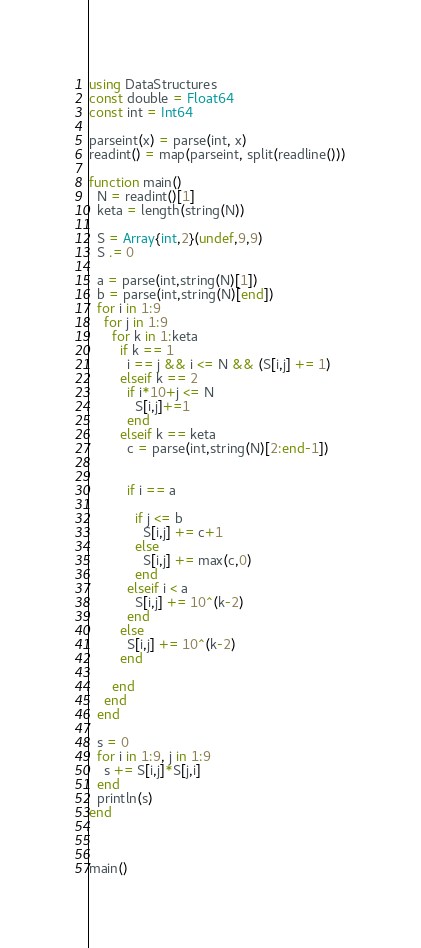Convert code to text. <code><loc_0><loc_0><loc_500><loc_500><_Julia_>using DataStructures
const double = Float64
const int = Int64

parseint(x) = parse(int, x)
readint() = map(parseint, split(readline()))

function main()
  N = readint()[1]
  keta = length(string(N))
  
  S = Array{int,2}(undef,9,9)
  S .= 0
  
  a = parse(int,string(N)[1])
  b = parse(int,string(N)[end])
  for i in 1:9
    for j in 1:9
      for k in 1:keta
        if k == 1
          i == j && i <= N && (S[i,j] += 1)
        elseif k == 2
          if i*10+j <= N
            S[i,j]+=1
          end
        elseif k == keta
          c = parse(int,string(N)[2:end-1])

            
          if i == a
              
            if j <= b
              S[i,j] += c+1
            else
              S[i,j] += max(c,0)
            end
          elseif i < a         
            S[i,j] += 10^(k-2)
          end
        else
          S[i,j] += 10^(k-2)
        end
          
      end
    end
  end
  
  s = 0
  for i in 1:9, j in 1:9
    s += S[i,j]*S[j,i]
  end
  println(s)
end



main()</code> 